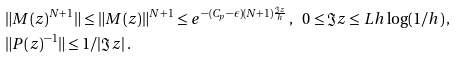<formula> <loc_0><loc_0><loc_500><loc_500>& \| M ( z ) ^ { N + 1 } \| \leq \| M ( z ) \| ^ { N + 1 } \leq e ^ { - ( C _ { p } - \epsilon ) ( N + 1 ) \frac { \Im z } { h } } \, , \ \ 0 \leq \Im z \leq L h \log ( 1 / h ) \, , \\ & \| P ( z ) ^ { - 1 } \| \leq 1 / | \Im z | \, .</formula> 